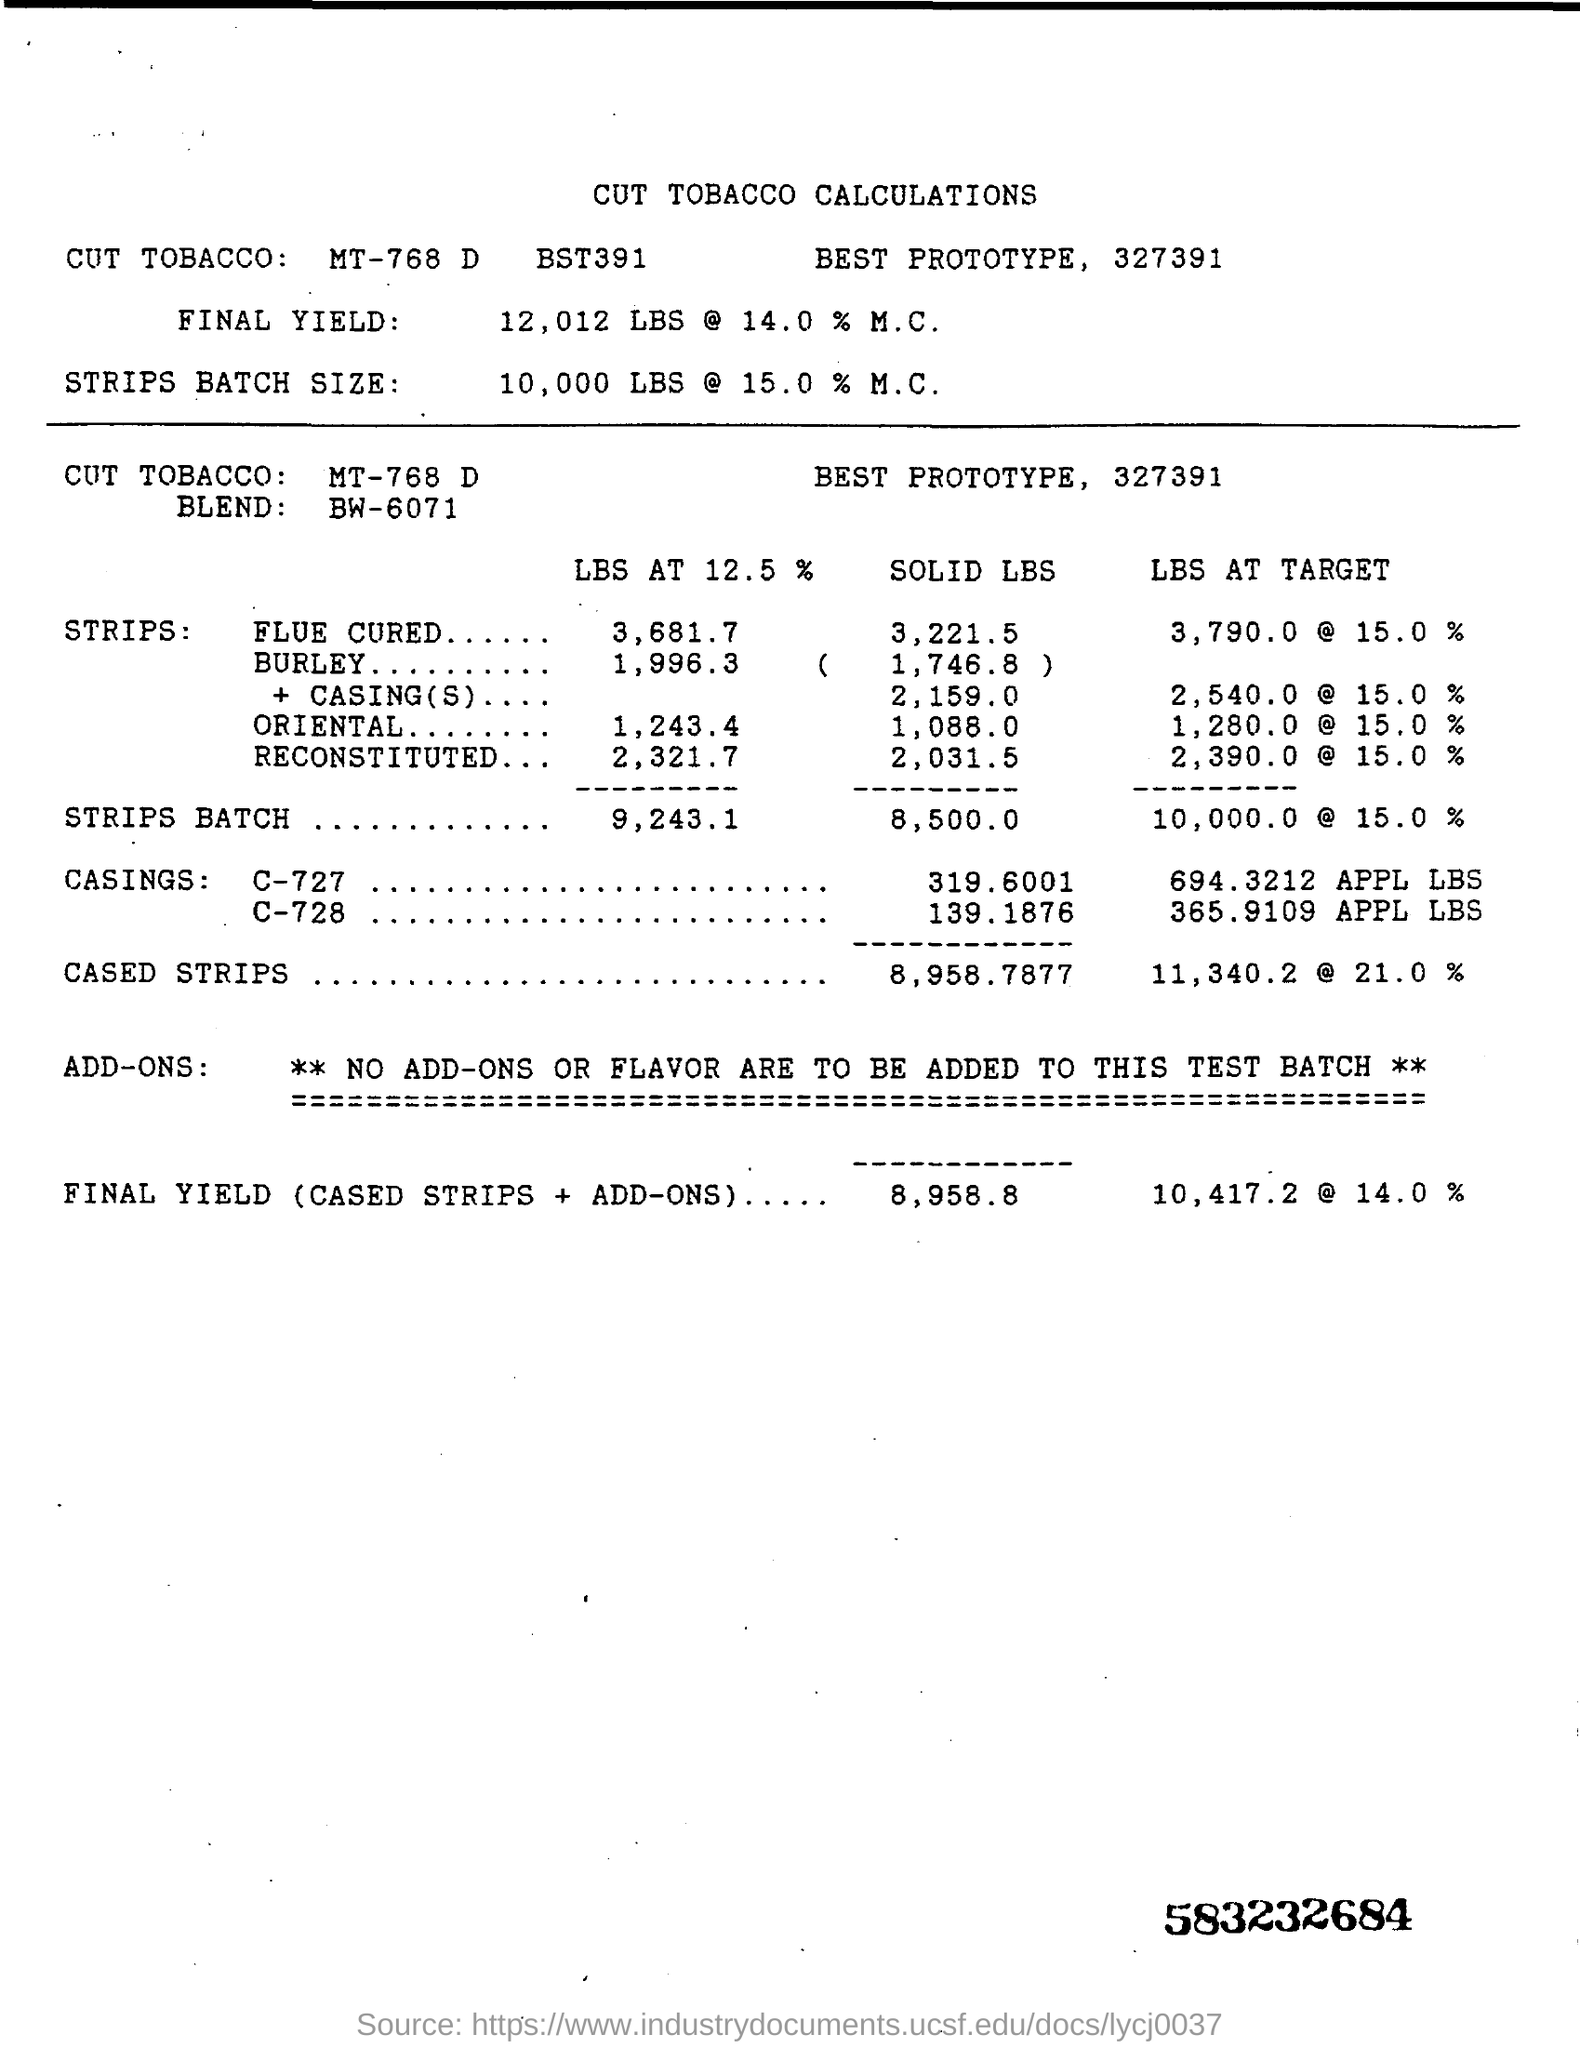What is the title?
Offer a very short reply. Cut Tobacco Calculations. What code is mentioned in the bottom right corner?
Provide a short and direct response. 583232684. 